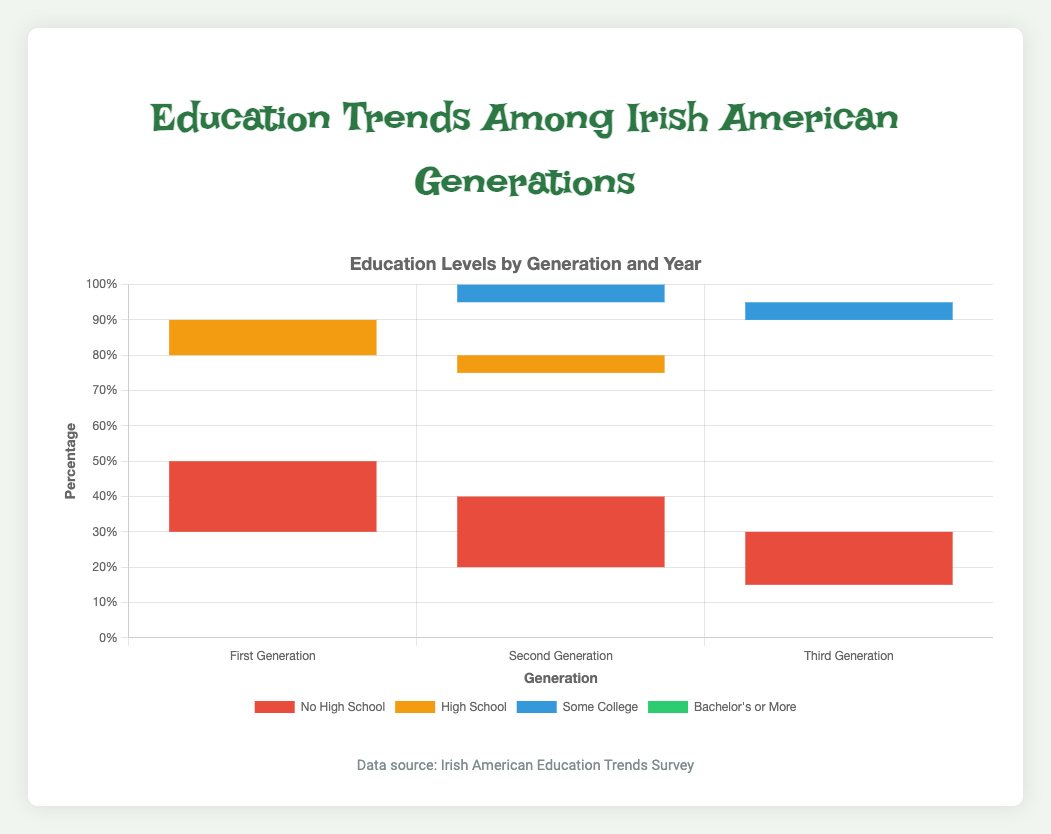Which generation had the highest percentage of Bachelor's or more in 2010? The group bar chart shows the comparison among different education levels across generations. By observing the bar heights, we can see the third generation consistently in 2010 had the highest percentage.
Answer: Third Generation How did the percentage of high school education change for the first generation from 1950 to 2010? In 1950, the percentage of high school education for the first generation was 30%. By 2010, it decreased to 25%.
Answer: Decreased What is the total percentage of people who attained some college in the second generation across all three years? We need to sum up the percentages of some college for the second generation in 1950, 1980, and 2010. The values are 15%, 25%, and 35%, respectively. Adding them together: 15 + 25 + 35 = 75%.
Answer: 75% Which year showed the highest improvement in education for the first generation when comparing Bachelor's or more? By comparing the bars, we see that in 2010, the Bachelor's or more percentage for the first generation significantly increased from 10% in 1980 to 30% in 2010, indicating the highest improvement.
Answer: 2010 Between the first and third generations, which had a higher percentage of people with no high school education in 1980? By comparing the heights of the red bars in 1980 for both generations, the first generation at 30% and the third generation at 15%, the first generation had a higher percentage.
Answer: First Generation What is the difference in percentage of Bachelor's or more between the second and third generations in 2010? In 2010, the percentage for the second generation is 40%, and for the third generation, it is 45%. The difference is 45% - 40% = 5%.
Answer: 5% What was the trend for high school education from 1950 to 2010 across all generations? Observing the heights of the orange bars from 1950 to 2010 for all generations shows a consistent decrease. First generation: 30% to 25%; second generation: 35% to 20%; third generation: 40% to 20%.
Answer: Decreased Comparing some college education levels in 1980, which generation had the highest percentage? In 1980, the blue bars representing some college show that the second generation had the highest percentage at 25%, compared to the others.
Answer: Second Generation What is the change in no high school percentage for the third generation from 1950 to 2010? In 1950, the third generation had 30% and decreased to 3% in 2010. The change is 30% - 3% = 27%.
Answer: 27% 